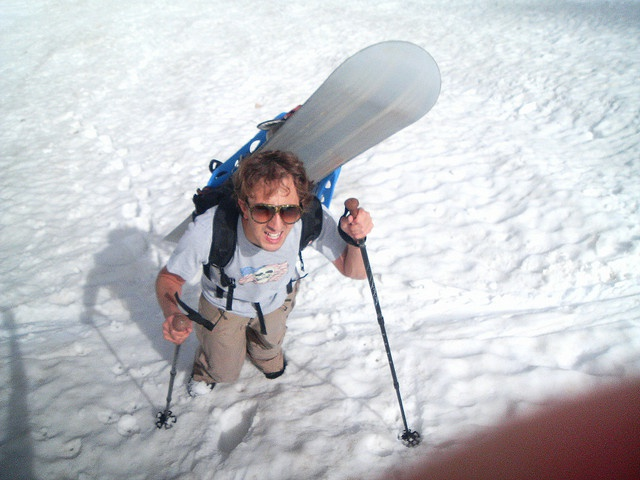Describe the objects in this image and their specific colors. I can see people in lightgray, darkgray, black, and gray tones, snowboard in lightgray, darkgray, and gray tones, and backpack in lightgray, black, navy, gray, and darkgray tones in this image. 